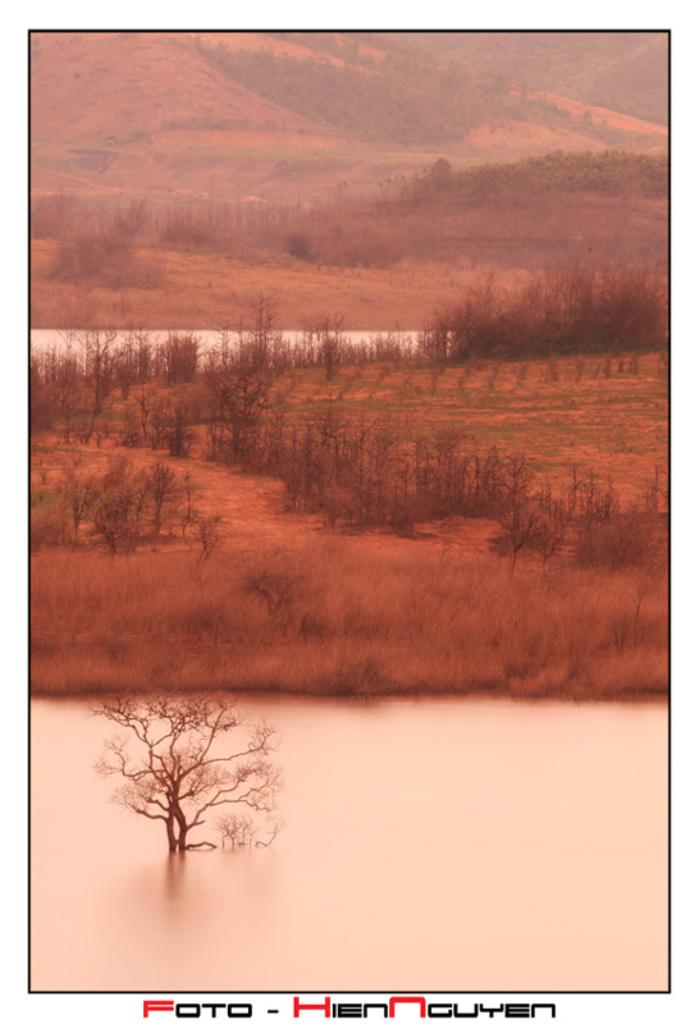What type of vegetation is present in the image? There is grass and plants in the image. Can you describe the water in the image? There is water visible in the image, and a plant is in the water. What type of landscape feature can be seen in the image? There are hills in the image. What type of furniture is visible in the image? There is no furniture present in the image. What song can be heard playing in the background of the image? There is no song or audio present in the image. 